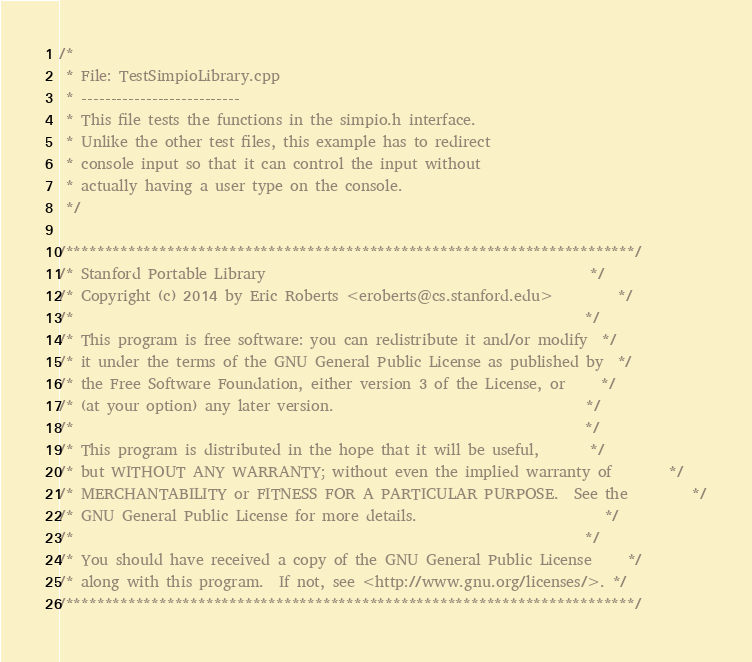<code> <loc_0><loc_0><loc_500><loc_500><_C++_>/*
 * File: TestSimpioLibrary.cpp
 * ---------------------------
 * This file tests the functions in the simpio.h interface.
 * Unlike the other test files, this example has to redirect
 * console input so that it can control the input without
 * actually having a user type on the console.
 */

/*************************************************************************/
/* Stanford Portable Library                                             */
/* Copyright (c) 2014 by Eric Roberts <eroberts@cs.stanford.edu>         */
/*                                                                       */
/* This program is free software: you can redistribute it and/or modify  */
/* it under the terms of the GNU General Public License as published by  */
/* the Free Software Foundation, either version 3 of the License, or     */
/* (at your option) any later version.                                   */
/*                                                                       */
/* This program is distributed in the hope that it will be useful,       */
/* but WITHOUT ANY WARRANTY; without even the implied warranty of        */
/* MERCHANTABILITY or FITNESS FOR A PARTICULAR PURPOSE.  See the         */
/* GNU General Public License for more details.                          */
/*                                                                       */
/* You should have received a copy of the GNU General Public License     */
/* along with this program.  If not, see <http://www.gnu.org/licenses/>. */
/*************************************************************************/
</code> 